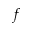Convert formula to latex. <formula><loc_0><loc_0><loc_500><loc_500>f</formula> 